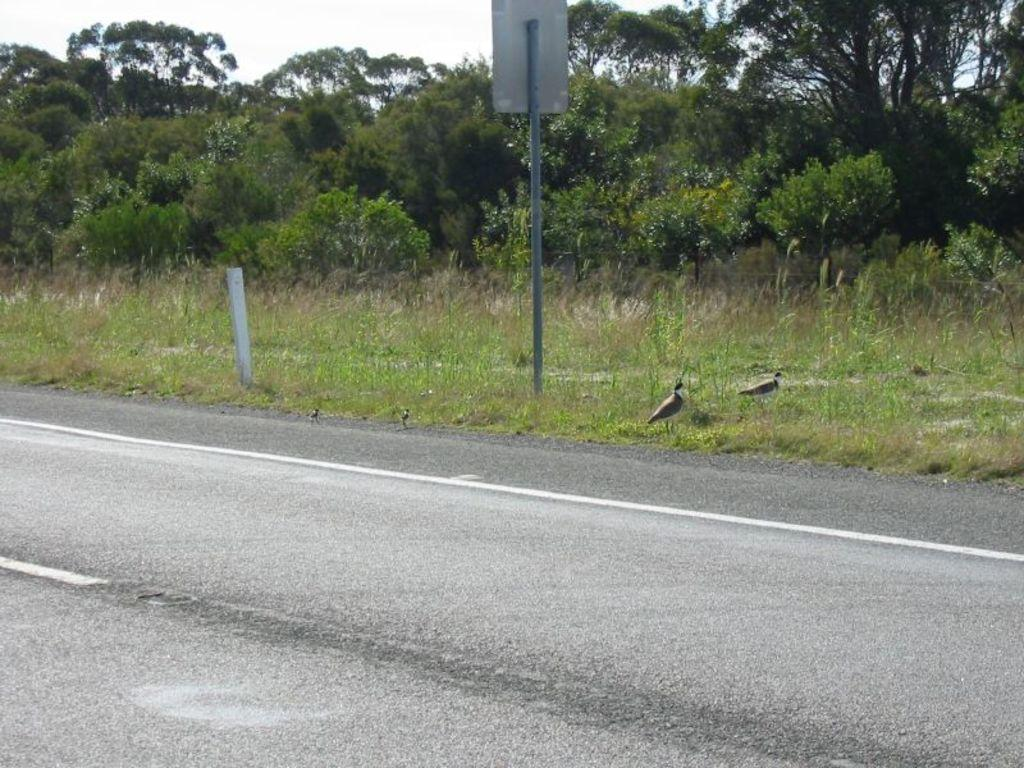What type of surface can be seen in the image? There is a road in the image. What object is made of metal in the image? There is a metal pole in the image. What is the board used for in the image? The purpose of the board in the image is not specified, but it is present. What type of vegetation is visible in the image? There is grass in the image. What type of animals can be seen in the image? There are black and white birds in the image. What else can be seen in the image besides the road and birds? There are trees in the image. What can be seen in the background of the image? The sky is visible in the background of the image. What type of fruit is hanging from the wing of the bird in the image? There are no fruits or wings visible in the image; it features black and white birds. What attraction is the bird visiting in the image? There is no attraction mentioned or visible in the image; it only shows the birds, trees, and other elements. 